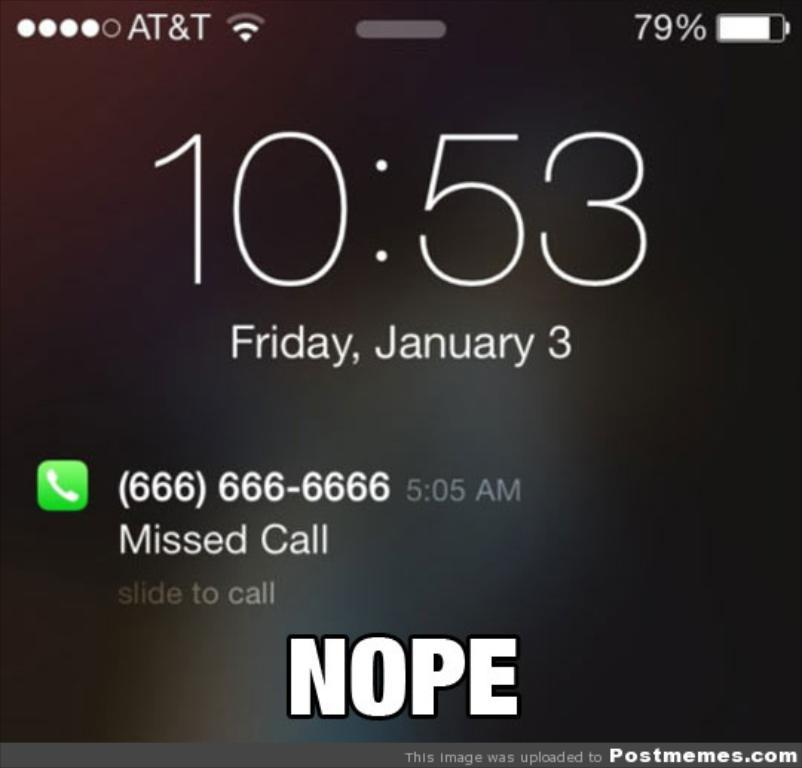Provide a one-sentence caption for the provided image. A phones lock screen that shows a missed call from a number. 